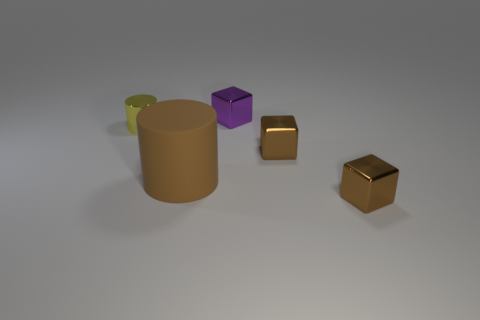How many objects are small things or small brown things in front of the large matte cylinder?
Your response must be concise. 4. How many small brown cubes are in front of the brown matte thing on the left side of the brown block that is in front of the brown rubber object?
Your response must be concise. 1. What material is the yellow cylinder that is the same size as the purple block?
Your answer should be compact. Metal. Is there a cyan matte thing that has the same size as the yellow shiny thing?
Your response must be concise. No. What is the color of the rubber cylinder?
Keep it short and to the point. Brown. What color is the tiny thing that is to the left of the object behind the tiny yellow cylinder?
Offer a very short reply. Yellow. There is a brown thing left of the small brown block that is to the left of the tiny brown thing that is in front of the big cylinder; what is its shape?
Keep it short and to the point. Cylinder. How many tiny yellow things are the same material as the big brown cylinder?
Make the answer very short. 0. How many large brown cylinders are left of the block that is behind the small cylinder?
Your response must be concise. 1. What number of brown blocks are there?
Offer a very short reply. 2. 